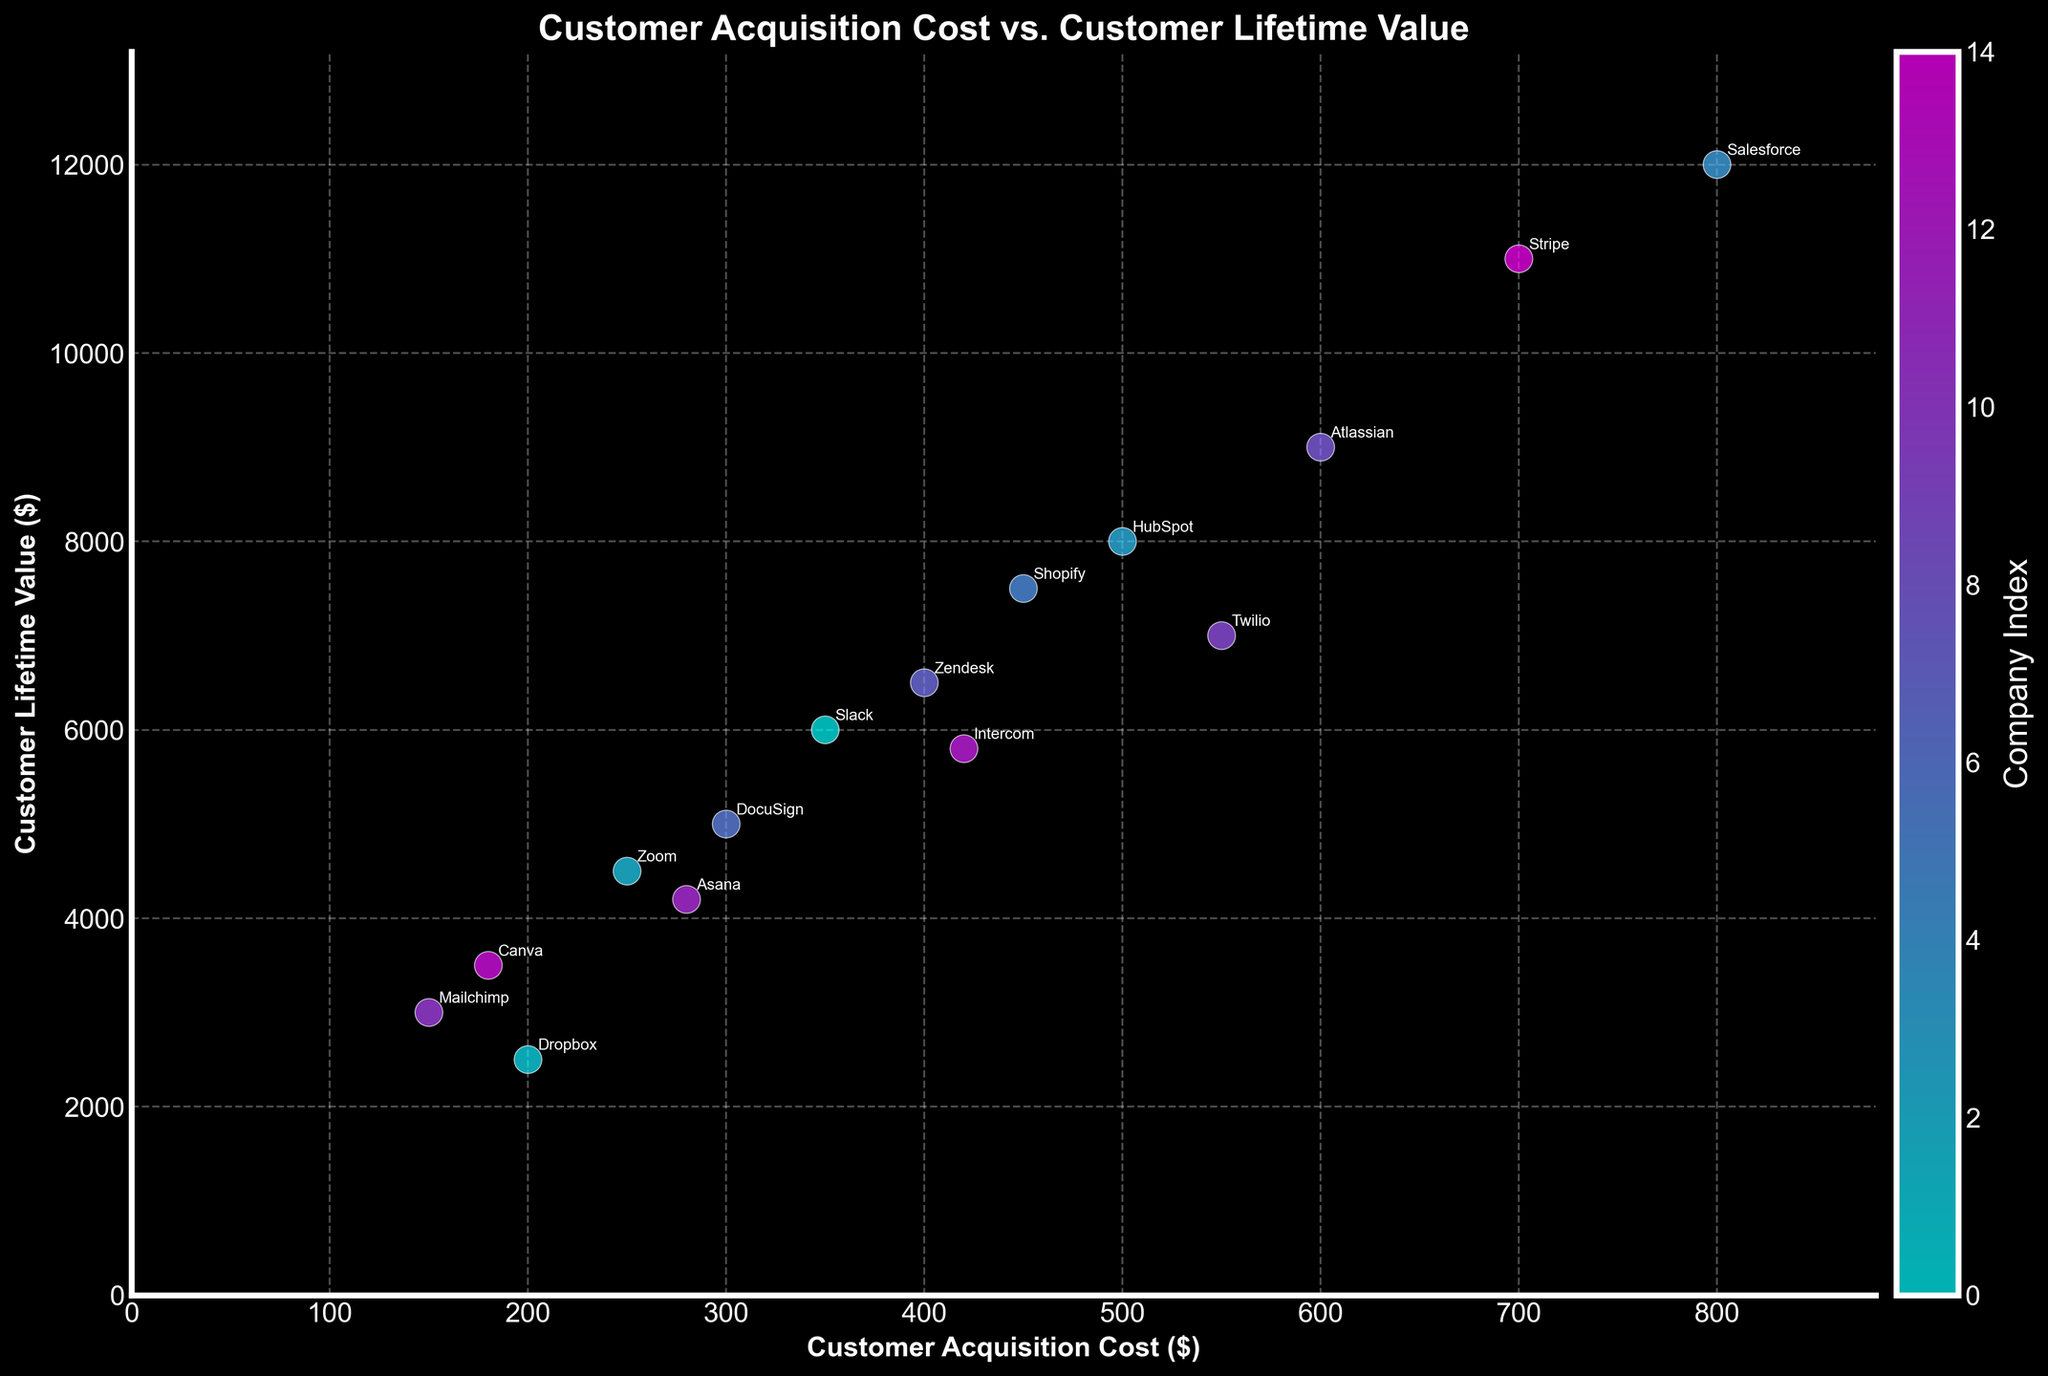What is the title of the figure? The title of a figure is typically located at the top and provides a summary of what the figure is about. In this case, the title is clearly labeled at the top of the scatter plot.
Answer: Customer Acquisition Cost vs. Customer Lifetime Value How many companies are represented in the figure? To determine the number of companies, count the number of data points in the scatter plot. Each point represents a company. From the data provided, there are 15 companies.
Answer: 15 Which company has the highest Customer Lifetime Value? To find the company with the highest Customer Lifetime Value, look for the data point that is positioned highest on the vertical axis. This company’s label is visible at the highest point on the y-axis. In this figure, that is Salesforce.
Answer: Salesforce What is the Customer Acquisition Cost and Customer Lifetime Value for Shopify? Locate the data point labeled "Shopify" on the scatter plot. The x-coordinate represents the Customer Acquisition Cost, and the y-coordinate represents the Customer Lifetime Value. From the plot, Shopify has a Customer Acquisition Cost of $450 and a Customer Lifetime Value of $7500.
Answer: Customer Acquisition Cost: $450, Customer Lifetime Value: $7500 Are there more companies with a Customer Acquisition Cost above $500 or below $500? Count the data points where the x-coordinates (Customer Acquisition Cost) are above $500 and compare it to the count where the x-coordinates are below $500. From the scatter plot, there are 6 companies above $500 and 9 companies below $500.
Answer: Below $500 Which two companies have the closest Customer Lifetime Value? Examine the y-coordinates of the data points to find two points that are closest together vertically. Intercom and Zendesk have similar y-coordinates with values of $5800 and $6500, respectively.
Answer: Intercom and Zendesk Which company has the highest ratio of Customer Lifetime Value to Customer Acquisition Cost? Calculate the ratio of Customer Lifetime Value to Customer Acquisition Cost for each company and compare. Salesforce has a ratio of 12000/800 = 15, which is the highest.
Answer: Salesforce What is the average Customer Acquisition Cost for the companies in the Communication industry? Identify the companies in the Communication industry and sum their Customer Acquisition Costs, then divide by the number of these companies. Only Slack (350) and Twilio (550) are in Communication, so the average is (350 + 550) / 2 = 450.
Answer: $450 Which industry has the widest range of Customer Acquisition Costs among its companies? Compare the difference between the highest and lowest Customer Acquisition Costs within each industry. There are various industries with only one company, but comparing multiple companies like in Communication and others, Communication (Slack 350, Twilio 550), the range is 200; in other industries, the range is zero with only one company example. Therefore, Communication has the widest range.
Answer: Communication 